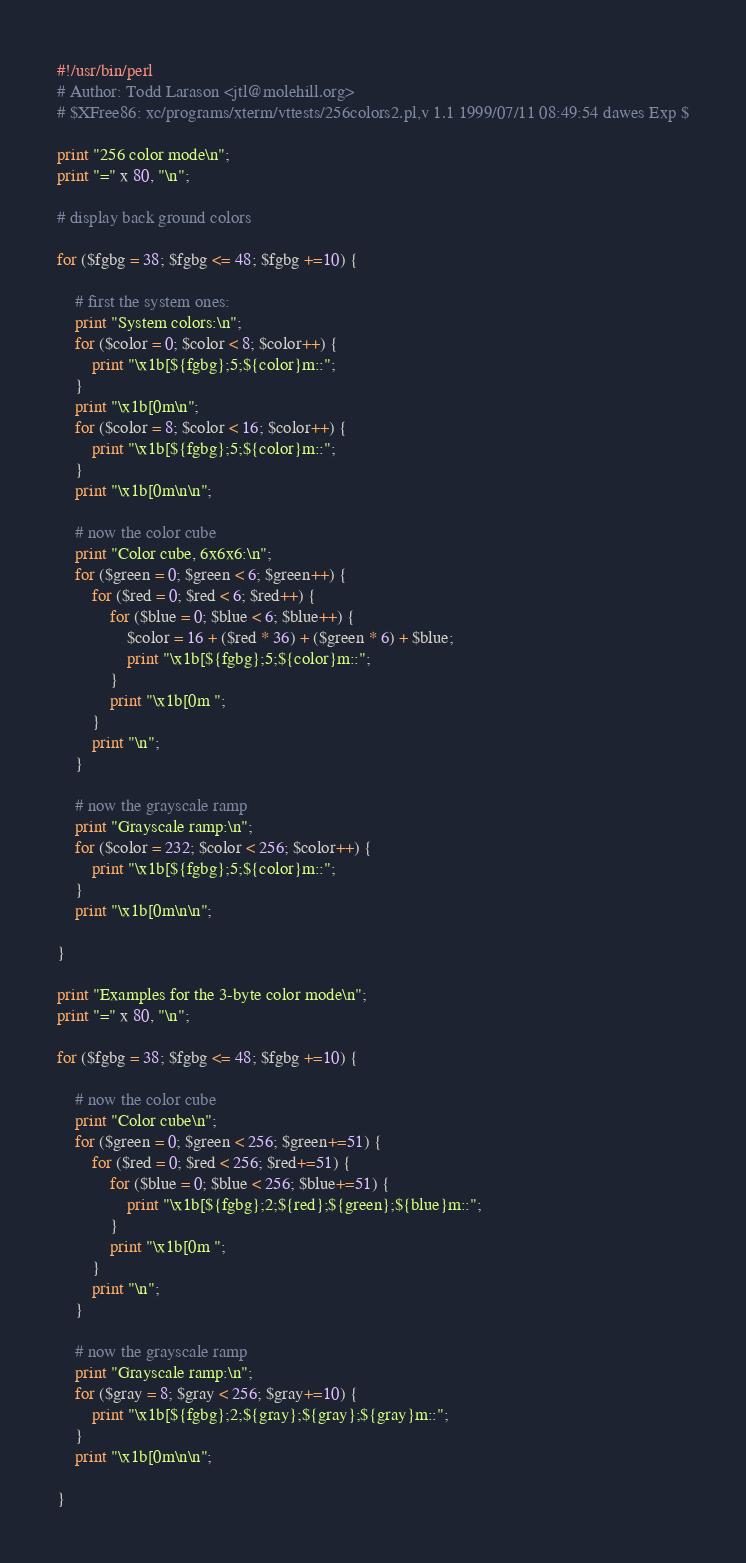<code> <loc_0><loc_0><loc_500><loc_500><_Perl_>#!/usr/bin/perl
# Author: Todd Larason <jtl@molehill.org>
# $XFree86: xc/programs/xterm/vttests/256colors2.pl,v 1.1 1999/07/11 08:49:54 dawes Exp $

print "256 color mode\n";
print "=" x 80, "\n";

# display back ground colors

for ($fgbg = 38; $fgbg <= 48; $fgbg +=10) {

    # first the system ones:
    print "System colors:\n";
    for ($color = 0; $color < 8; $color++) {
        print "\x1b[${fgbg};5;${color}m::";
    }
    print "\x1b[0m\n";
    for ($color = 8; $color < 16; $color++) {
        print "\x1b[${fgbg};5;${color}m::";
    }
    print "\x1b[0m\n\n";

    # now the color cube
    print "Color cube, 6x6x6:\n";
    for ($green = 0; $green < 6; $green++) {
        for ($red = 0; $red < 6; $red++) {
            for ($blue = 0; $blue < 6; $blue++) {
                $color = 16 + ($red * 36) + ($green * 6) + $blue;
                print "\x1b[${fgbg};5;${color}m::";
            }
            print "\x1b[0m ";
        }
        print "\n";
    }

    # now the grayscale ramp
    print "Grayscale ramp:\n";
    for ($color = 232; $color < 256; $color++) {
        print "\x1b[${fgbg};5;${color}m::";
    }
    print "\x1b[0m\n\n";

}

print "Examples for the 3-byte color mode\n";
print "=" x 80, "\n";

for ($fgbg = 38; $fgbg <= 48; $fgbg +=10) {

    # now the color cube
    print "Color cube\n";
    for ($green = 0; $green < 256; $green+=51) {
        for ($red = 0; $red < 256; $red+=51) {
            for ($blue = 0; $blue < 256; $blue+=51) {
                print "\x1b[${fgbg};2;${red};${green};${blue}m::";
            }
            print "\x1b[0m ";
        }
        print "\n";
    }

    # now the grayscale ramp
    print "Grayscale ramp:\n";
    for ($gray = 8; $gray < 256; $gray+=10) {
        print "\x1b[${fgbg};2;${gray};${gray};${gray}m::";
    }
    print "\x1b[0m\n\n";

}
</code> 